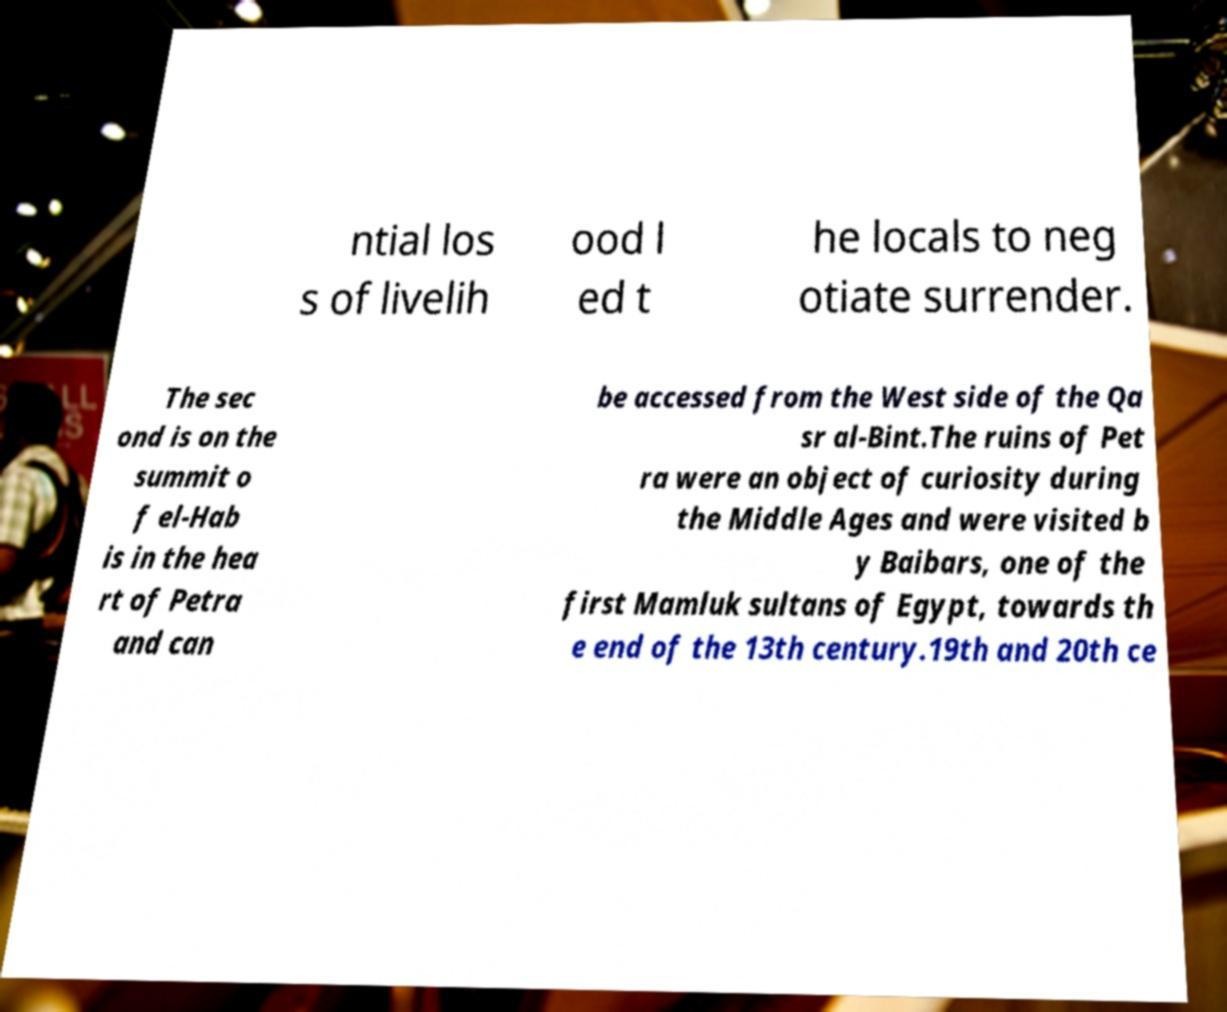Could you extract and type out the text from this image? ntial los s of livelih ood l ed t he locals to neg otiate surrender. The sec ond is on the summit o f el-Hab is in the hea rt of Petra and can be accessed from the West side of the Qa sr al-Bint.The ruins of Pet ra were an object of curiosity during the Middle Ages and were visited b y Baibars, one of the first Mamluk sultans of Egypt, towards th e end of the 13th century.19th and 20th ce 